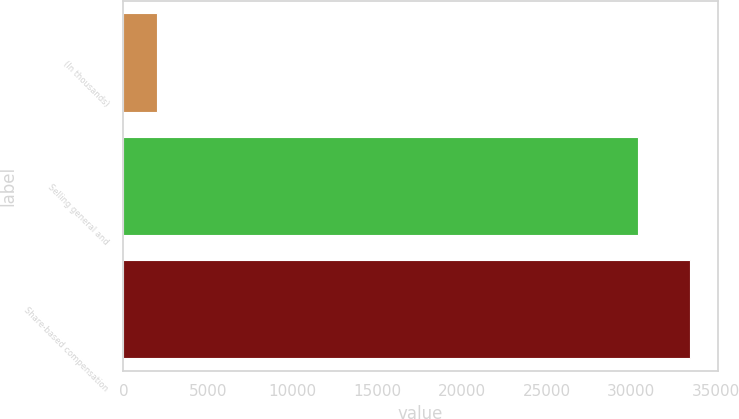Convert chart. <chart><loc_0><loc_0><loc_500><loc_500><bar_chart><fcel>(In thousands)<fcel>Selling general and<fcel>Share-based compensation<nl><fcel>2007<fcel>30379<fcel>33447.1<nl></chart> 